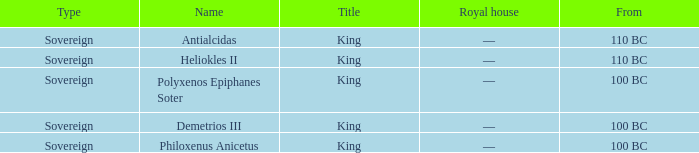Which royal house corresponds to Polyxenos Epiphanes Soter? —. 